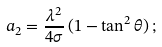<formula> <loc_0><loc_0><loc_500><loc_500>a _ { 2 } = { \frac { \lambda ^ { 2 } } { 4 \sigma } } \, ( 1 - \tan ^ { 2 } \theta ) \, ;</formula> 